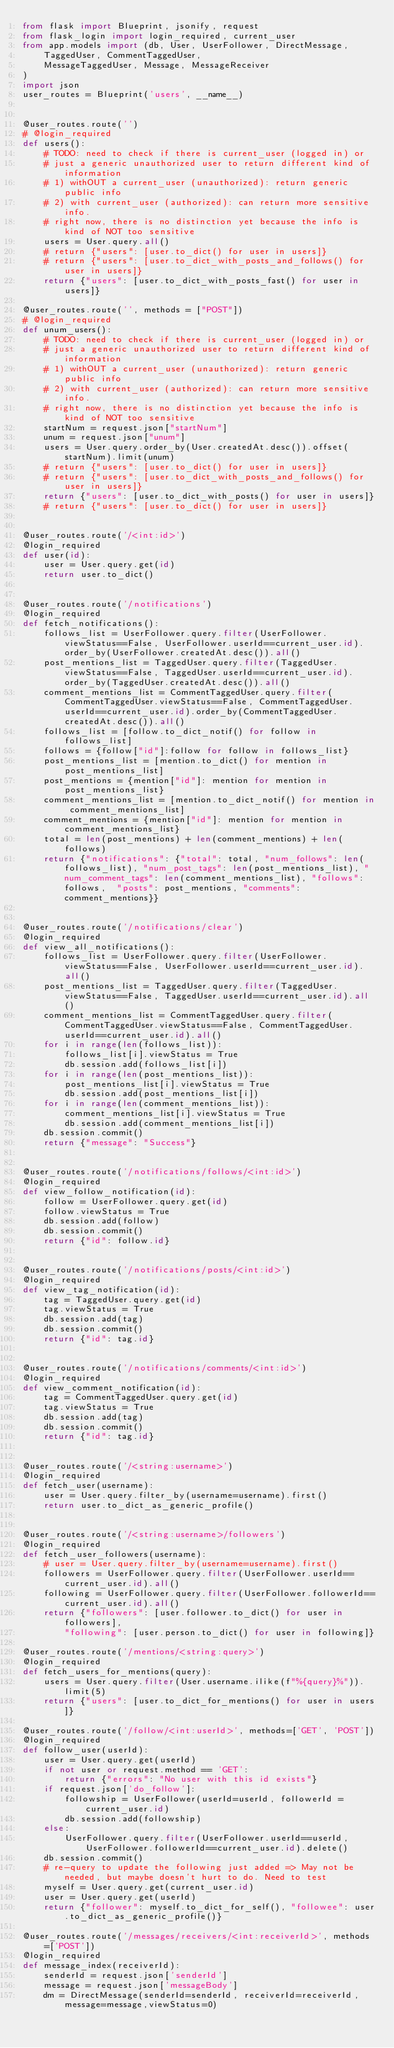<code> <loc_0><loc_0><loc_500><loc_500><_Python_>from flask import Blueprint, jsonify, request
from flask_login import login_required, current_user
from app.models import (db, User, UserFollower, DirectMessage, 
    TaggedUser, CommentTaggedUser,
    MessageTaggedUser, Message, MessageReceiver
)
import json
user_routes = Blueprint('users', __name__)


@user_routes.route('')
# @login_required
def users():
    # TODO: need to check if there is current_user (logged in) or 
    # just a generic unauthorized user to return different kind of information
    # 1) withOUT a current_user (unauthorized): return generic public info
    # 2) with current_user (authorized): can return more sensitive info.
    # right now, there is no distinction yet because the info is kind of NOT too sensitive
    users = User.query.all()
    # return {"users": [user.to_dict() for user in users]}
    # return {"users": [user.to_dict_with_posts_and_follows() for user in users]}
    return {"users": [user.to_dict_with_posts_fast() for user in users]}

@user_routes.route('', methods = ["POST"])
# @login_required
def unum_users():
    # TODO: need to check if there is current_user (logged in) or 
    # just a generic unauthorized user to return different kind of information
    # 1) withOUT a current_user (unauthorized): return generic public info
    # 2) with current_user (authorized): can return more sensitive info.
    # right now, there is no distinction yet because the info is kind of NOT too sensitive
    startNum = request.json["startNum"]
    unum = request.json["unum"]
    users = User.query.order_by(User.createdAt.desc()).offset(startNum).limit(unum)
    # return {"users": [user.to_dict() for user in users]}
    # return {"users": [user.to_dict_with_posts_and_follows() for user in users]}
    return {"users": [user.to_dict_with_posts() for user in users]}
    # return {"users": [user.to_dict() for user in users]}


@user_routes.route('/<int:id>')
@login_required
def user(id):
    user = User.query.get(id)
    return user.to_dict()


@user_routes.route('/notifications')
@login_required
def fetch_notifications():
    follows_list = UserFollower.query.filter(UserFollower.viewStatus==False, UserFollower.userId==current_user.id).order_by(UserFollower.createdAt.desc()).all()
    post_mentions_list = TaggedUser.query.filter(TaggedUser.viewStatus==False, TaggedUser.userId==current_user.id).order_by(TaggedUser.createdAt.desc()).all()
    comment_mentions_list = CommentTaggedUser.query.filter(CommentTaggedUser.viewStatus==False, CommentTaggedUser.userId==current_user.id).order_by(CommentTaggedUser.createdAt.desc()).all()
    follows_list = [follow.to_dict_notif() for follow in follows_list]
    follows = {follow["id"]:follow for follow in follows_list}
    post_mentions_list = [mention.to_dict() for mention in post_mentions_list]
    post_mentions = {mention["id"]: mention for mention in post_mentions_list}
    comment_mentions_list = [mention.to_dict_notif() for mention in comment_mentions_list]
    comment_mentions = {mention["id"]: mention for mention in comment_mentions_list}
    total = len(post_mentions) + len(comment_mentions) + len(follows)
    return {"notifications": {"total": total, "num_follows": len(follows_list), "num_post_tags": len(post_mentions_list), "num_comment_tags": len(comment_mentions_list), "follows": follows,  "posts": post_mentions, "comments": comment_mentions}}


@user_routes.route('/notifications/clear')
@login_required
def view_all_notifications():
    follows_list = UserFollower.query.filter(UserFollower.viewStatus==False, UserFollower.userId==current_user.id).all()
    post_mentions_list = TaggedUser.query.filter(TaggedUser.viewStatus==False, TaggedUser.userId==current_user.id).all()
    comment_mentions_list = CommentTaggedUser.query.filter(CommentTaggedUser.viewStatus==False, CommentTaggedUser.userId==current_user.id).all()
    for i in range(len(follows_list)):
        follows_list[i].viewStatus = True
        db.session.add(follows_list[i])
    for i in range(len(post_mentions_list)):
        post_mentions_list[i].viewStatus = True
        db.session.add(post_mentions_list[i])
    for i in range(len(comment_mentions_list)):
        comment_mentions_list[i].viewStatus = True
        db.session.add(comment_mentions_list[i])
    db.session.commit()
    return {"message": "Success"}


@user_routes.route('/notifications/follows/<int:id>')
@login_required
def view_follow_notification(id):
    follow = UserFollower.query.get(id)
    follow.viewStatus = True
    db.session.add(follow)
    db.session.commit()
    return {"id": follow.id}


@user_routes.route('/notifications/posts/<int:id>')
@login_required
def view_tag_notification(id):
    tag = TaggedUser.query.get(id)
    tag.viewStatus = True
    db.session.add(tag)
    db.session.commit()
    return {"id": tag.id}


@user_routes.route('/notifications/comments/<int:id>')
@login_required
def view_comment_notification(id):
    tag = CommentTaggedUser.query.get(id)
    tag.viewStatus = True
    db.session.add(tag)
    db.session.commit()
    return {"id": tag.id}


@user_routes.route('/<string:username>')
@login_required
def fetch_user(username):
    user = User.query.filter_by(username=username).first()
    return user.to_dict_as_generic_profile()


@user_routes.route('/<string:username>/followers')
@login_required
def fetch_user_followers(username):
    # user = User.query.filter_by(username=username).first()
    followers = UserFollower.query.filter(UserFollower.userId==current_user.id).all()
    following = UserFollower.query.filter(UserFollower.followerId==current_user.id).all()
    return {"followers": [user.follower.to_dict() for user in followers], 
        "following": [user.person.to_dict() for user in following]}

@user_routes.route('/mentions/<string:query>')
@login_required
def fetch_users_for_mentions(query):
    users = User.query.filter(User.username.ilike(f"%{query}%")).limit(5)
    return {"users": [user.to_dict_for_mentions() for user in users]}

@user_routes.route('/follow/<int:userId>', methods=['GET', 'POST'])
@login_required
def follow_user(userId):
    user = User.query.get(userId)
    if not user or request.method == 'GET':
        return {"errors": "No user with this id exists"}
    if request.json['do_follow']:
        followship = UserFollower(userId=userId, followerId = current_user.id)
        db.session.add(followship)
    else:
        UserFollower.query.filter(UserFollower.userId==userId, UserFollower.followerId==current_user.id).delete()
    db.session.commit()
    # re-query to update the following just added => May not be needed, but maybe doesn't hurt to do. Need to test    
    myself = User.query.get(current_user.id)
    user = User.query.get(userId) 
    return {"follower": myself.to_dict_for_self(), "followee": user.to_dict_as_generic_profile()}

@user_routes.route('/messages/receivers/<int:receiverId>', methods=['POST'])
@login_required
def message_index(receiverId):
    senderId = request.json['senderId']
    message = request.json['messageBody']
    dm = DirectMessage(senderId=senderId, receiverId=receiverId,message=message,viewStatus=0)</code> 